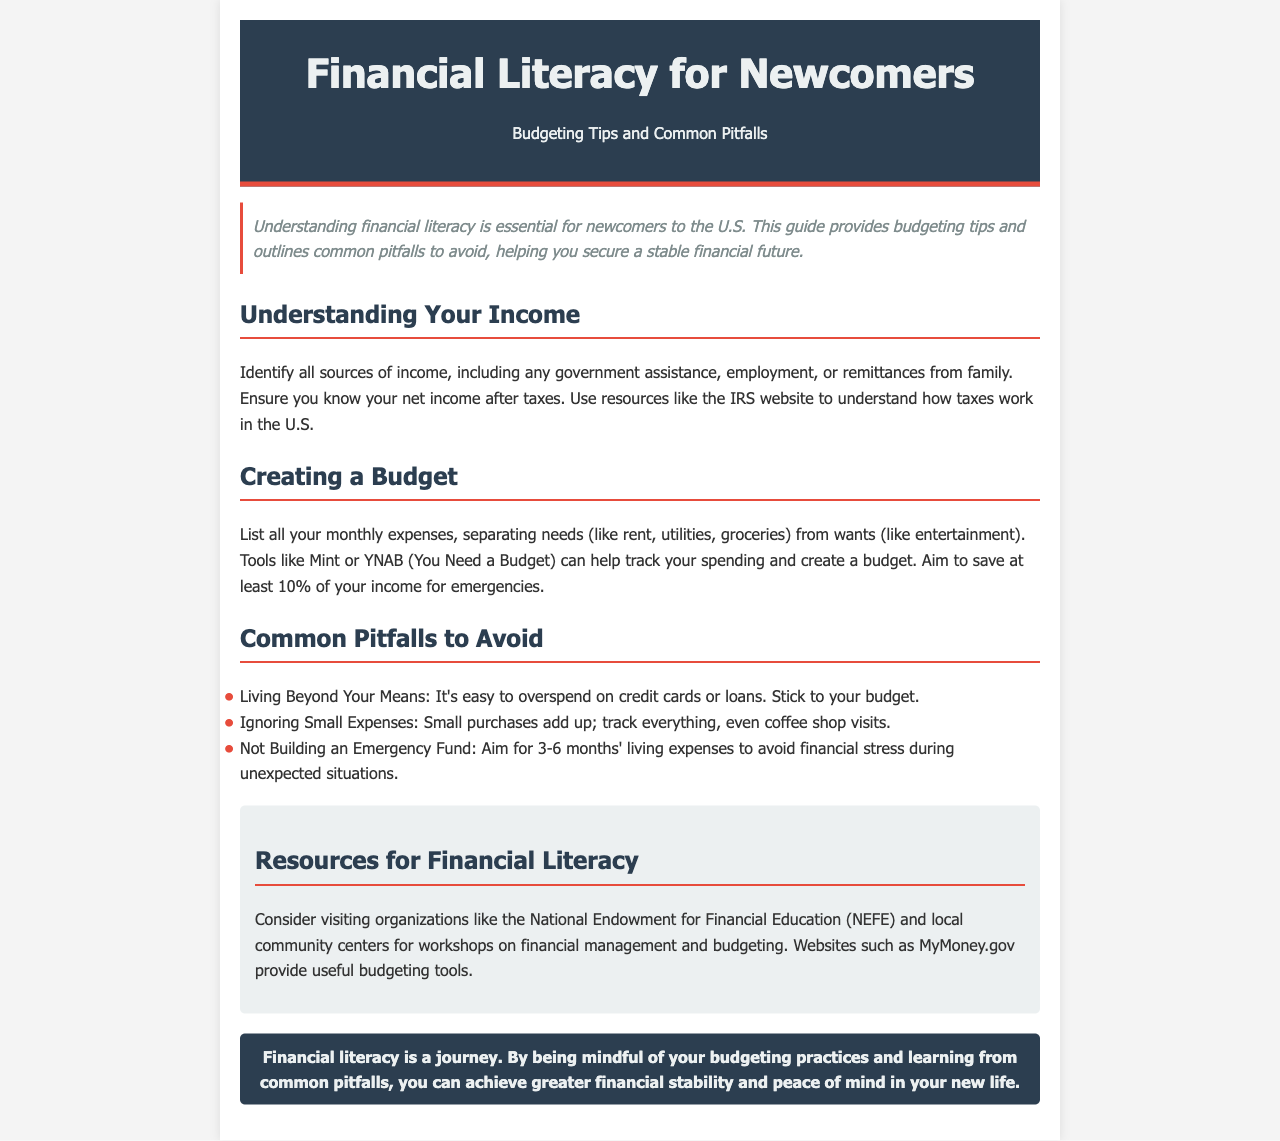what is the main topic of the newsletter? The main topic of the newsletter is about financial literacy, specifically budgeting tips and common pitfalls for newcomers.
Answer: Financial Literacy for Newcomers how much should you aim to save from your income for emergencies? The document states that you should aim to save at least 10% of your income for emergencies.
Answer: 10% what is one tool suggested for tracking spending? The newsletter recommends Mint or YNAB as tools to help track spending and create a budget.
Answer: Mint how many months' living expenses should be saved for an emergency fund? The document mentions aiming for 3-6 months' living expenses for an emergency fund.
Answer: 3-6 months which organization is mentioned for financial literacy resources? The National Endowment for Financial Education (NEFE) is one of the organizations suggested for resources on financial literacy.
Answer: NEFE what should be separated in a monthly expense list? The newsletter advises separating needs (like rent, utilities, groceries) from wants (like entertainment) in a monthly expense list.
Answer: Needs and wants what is a common pitfall regarding small expenses? The document warns about ignoring small expenses because they can add up over time.
Answer: Ignoring small expenses who should visit local community centers? Newcomers to the U.S. should consider visiting local community centers for workshops on financial management.
Answer: Newcomers what is the overall goal of understanding financial literacy according to the newsletter? The overarching goal is to achieve greater financial stability and peace of mind in one's new life.
Answer: Financial stability and peace of mind 